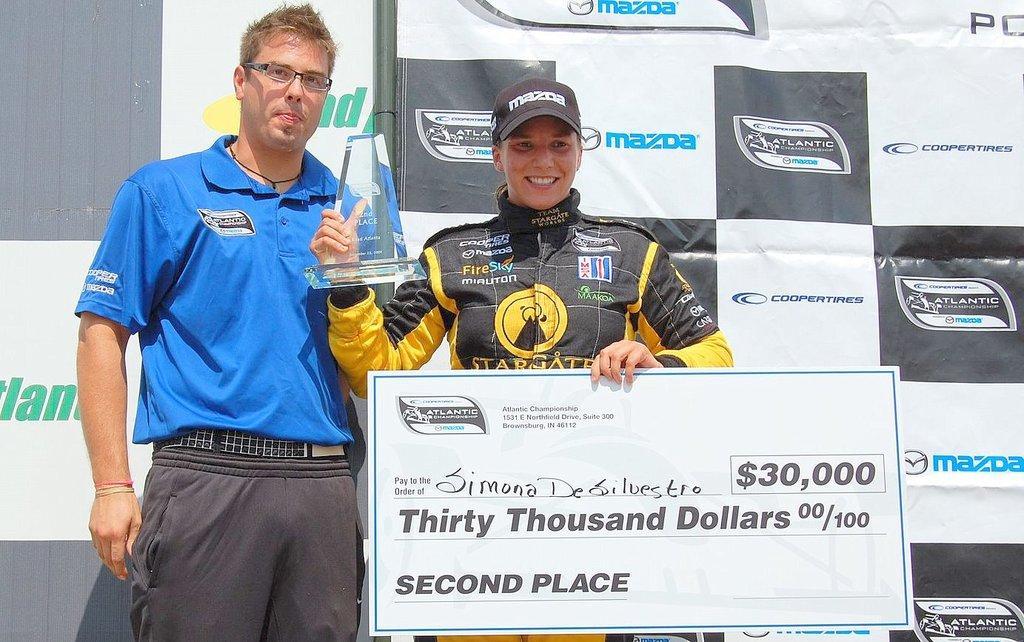Describe this image in one or two sentences. In this image there is one man and one woman standing, and a woman is holding a board and trophy. And in the background there are some boards, on the boards there is text and in the center there is one pole. 